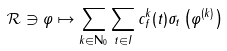Convert formula to latex. <formula><loc_0><loc_0><loc_500><loc_500>\mathcal { R } \ni \varphi \mapsto \sum _ { k \in \mathbf N _ { 0 } } \sum _ { t \in I } c ^ { k } _ { f } ( t ) \sigma _ { t } \left ( \varphi ^ { ( k ) } \right )</formula> 